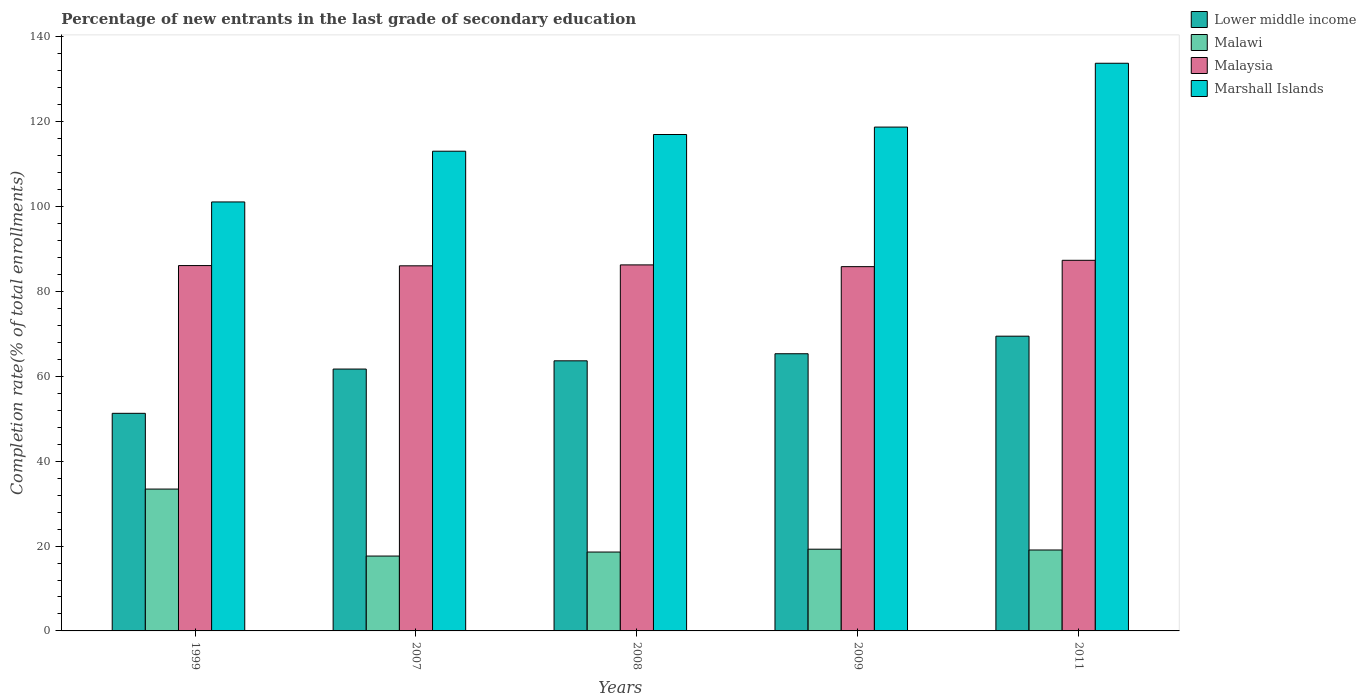How many different coloured bars are there?
Offer a terse response. 4. How many groups of bars are there?
Your answer should be compact. 5. Are the number of bars on each tick of the X-axis equal?
Your response must be concise. Yes. How many bars are there on the 1st tick from the left?
Your response must be concise. 4. How many bars are there on the 2nd tick from the right?
Give a very brief answer. 4. What is the label of the 1st group of bars from the left?
Your answer should be very brief. 1999. What is the percentage of new entrants in Lower middle income in 1999?
Offer a terse response. 51.28. Across all years, what is the maximum percentage of new entrants in Lower middle income?
Provide a succinct answer. 69.46. Across all years, what is the minimum percentage of new entrants in Malaysia?
Give a very brief answer. 85.85. In which year was the percentage of new entrants in Malaysia maximum?
Give a very brief answer. 2011. In which year was the percentage of new entrants in Malaysia minimum?
Make the answer very short. 2009. What is the total percentage of new entrants in Marshall Islands in the graph?
Ensure brevity in your answer.  583.65. What is the difference between the percentage of new entrants in Lower middle income in 2009 and that in 2011?
Provide a succinct answer. -4.14. What is the difference between the percentage of new entrants in Malawi in 2007 and the percentage of new entrants in Malaysia in 1999?
Provide a short and direct response. -68.46. What is the average percentage of new entrants in Marshall Islands per year?
Ensure brevity in your answer.  116.73. In the year 2007, what is the difference between the percentage of new entrants in Malaysia and percentage of new entrants in Lower middle income?
Give a very brief answer. 24.33. What is the ratio of the percentage of new entrants in Marshall Islands in 2009 to that in 2011?
Your response must be concise. 0.89. Is the difference between the percentage of new entrants in Malaysia in 2008 and 2011 greater than the difference between the percentage of new entrants in Lower middle income in 2008 and 2011?
Ensure brevity in your answer.  Yes. What is the difference between the highest and the second highest percentage of new entrants in Lower middle income?
Your response must be concise. 4.14. What is the difference between the highest and the lowest percentage of new entrants in Marshall Islands?
Provide a short and direct response. 32.68. Is it the case that in every year, the sum of the percentage of new entrants in Lower middle income and percentage of new entrants in Malaysia is greater than the sum of percentage of new entrants in Marshall Islands and percentage of new entrants in Malawi?
Offer a very short reply. Yes. What does the 4th bar from the left in 1999 represents?
Ensure brevity in your answer.  Marshall Islands. What does the 2nd bar from the right in 2009 represents?
Your answer should be compact. Malaysia. How many years are there in the graph?
Give a very brief answer. 5. What is the difference between two consecutive major ticks on the Y-axis?
Ensure brevity in your answer.  20. Are the values on the major ticks of Y-axis written in scientific E-notation?
Provide a succinct answer. No. How many legend labels are there?
Your answer should be very brief. 4. How are the legend labels stacked?
Give a very brief answer. Vertical. What is the title of the graph?
Your answer should be compact. Percentage of new entrants in the last grade of secondary education. What is the label or title of the Y-axis?
Your answer should be compact. Completion rate(% of total enrollments). What is the Completion rate(% of total enrollments) in Lower middle income in 1999?
Give a very brief answer. 51.28. What is the Completion rate(% of total enrollments) of Malawi in 1999?
Make the answer very short. 33.43. What is the Completion rate(% of total enrollments) in Malaysia in 1999?
Your response must be concise. 86.1. What is the Completion rate(% of total enrollments) in Marshall Islands in 1999?
Provide a succinct answer. 101.1. What is the Completion rate(% of total enrollments) of Lower middle income in 2007?
Offer a very short reply. 61.71. What is the Completion rate(% of total enrollments) of Malawi in 2007?
Your answer should be very brief. 17.64. What is the Completion rate(% of total enrollments) of Malaysia in 2007?
Your response must be concise. 86.04. What is the Completion rate(% of total enrollments) in Marshall Islands in 2007?
Offer a very short reply. 113.05. What is the Completion rate(% of total enrollments) of Lower middle income in 2008?
Offer a very short reply. 63.65. What is the Completion rate(% of total enrollments) in Malawi in 2008?
Your answer should be compact. 18.59. What is the Completion rate(% of total enrollments) in Malaysia in 2008?
Your answer should be very brief. 86.26. What is the Completion rate(% of total enrollments) of Marshall Islands in 2008?
Offer a very short reply. 116.99. What is the Completion rate(% of total enrollments) in Lower middle income in 2009?
Your answer should be compact. 65.32. What is the Completion rate(% of total enrollments) in Malawi in 2009?
Ensure brevity in your answer.  19.26. What is the Completion rate(% of total enrollments) in Malaysia in 2009?
Your response must be concise. 85.85. What is the Completion rate(% of total enrollments) of Marshall Islands in 2009?
Offer a very short reply. 118.74. What is the Completion rate(% of total enrollments) of Lower middle income in 2011?
Your answer should be very brief. 69.46. What is the Completion rate(% of total enrollments) of Malawi in 2011?
Keep it short and to the point. 19.07. What is the Completion rate(% of total enrollments) of Malaysia in 2011?
Your response must be concise. 87.34. What is the Completion rate(% of total enrollments) of Marshall Islands in 2011?
Provide a succinct answer. 133.78. Across all years, what is the maximum Completion rate(% of total enrollments) of Lower middle income?
Your response must be concise. 69.46. Across all years, what is the maximum Completion rate(% of total enrollments) in Malawi?
Your answer should be compact. 33.43. Across all years, what is the maximum Completion rate(% of total enrollments) of Malaysia?
Offer a terse response. 87.34. Across all years, what is the maximum Completion rate(% of total enrollments) in Marshall Islands?
Your answer should be very brief. 133.78. Across all years, what is the minimum Completion rate(% of total enrollments) in Lower middle income?
Give a very brief answer. 51.28. Across all years, what is the minimum Completion rate(% of total enrollments) in Malawi?
Make the answer very short. 17.64. Across all years, what is the minimum Completion rate(% of total enrollments) of Malaysia?
Your response must be concise. 85.85. Across all years, what is the minimum Completion rate(% of total enrollments) of Marshall Islands?
Provide a succinct answer. 101.1. What is the total Completion rate(% of total enrollments) in Lower middle income in the graph?
Make the answer very short. 311.43. What is the total Completion rate(% of total enrollments) of Malawi in the graph?
Offer a very short reply. 107.99. What is the total Completion rate(% of total enrollments) of Malaysia in the graph?
Offer a terse response. 431.6. What is the total Completion rate(% of total enrollments) in Marshall Islands in the graph?
Provide a succinct answer. 583.65. What is the difference between the Completion rate(% of total enrollments) in Lower middle income in 1999 and that in 2007?
Offer a very short reply. -10.43. What is the difference between the Completion rate(% of total enrollments) of Malawi in 1999 and that in 2007?
Ensure brevity in your answer.  15.78. What is the difference between the Completion rate(% of total enrollments) of Malaysia in 1999 and that in 2007?
Offer a very short reply. 0.06. What is the difference between the Completion rate(% of total enrollments) in Marshall Islands in 1999 and that in 2007?
Your answer should be compact. -11.96. What is the difference between the Completion rate(% of total enrollments) in Lower middle income in 1999 and that in 2008?
Your response must be concise. -12.37. What is the difference between the Completion rate(% of total enrollments) of Malawi in 1999 and that in 2008?
Provide a short and direct response. 14.84. What is the difference between the Completion rate(% of total enrollments) in Malaysia in 1999 and that in 2008?
Offer a very short reply. -0.16. What is the difference between the Completion rate(% of total enrollments) in Marshall Islands in 1999 and that in 2008?
Provide a short and direct response. -15.89. What is the difference between the Completion rate(% of total enrollments) in Lower middle income in 1999 and that in 2009?
Offer a very short reply. -14.04. What is the difference between the Completion rate(% of total enrollments) in Malawi in 1999 and that in 2009?
Give a very brief answer. 14.17. What is the difference between the Completion rate(% of total enrollments) of Malaysia in 1999 and that in 2009?
Make the answer very short. 0.26. What is the difference between the Completion rate(% of total enrollments) of Marshall Islands in 1999 and that in 2009?
Give a very brief answer. -17.64. What is the difference between the Completion rate(% of total enrollments) in Lower middle income in 1999 and that in 2011?
Offer a very short reply. -18.18. What is the difference between the Completion rate(% of total enrollments) in Malawi in 1999 and that in 2011?
Provide a succinct answer. 14.36. What is the difference between the Completion rate(% of total enrollments) in Malaysia in 1999 and that in 2011?
Give a very brief answer. -1.24. What is the difference between the Completion rate(% of total enrollments) in Marshall Islands in 1999 and that in 2011?
Your response must be concise. -32.68. What is the difference between the Completion rate(% of total enrollments) of Lower middle income in 2007 and that in 2008?
Keep it short and to the point. -1.94. What is the difference between the Completion rate(% of total enrollments) in Malawi in 2007 and that in 2008?
Your response must be concise. -0.94. What is the difference between the Completion rate(% of total enrollments) of Malaysia in 2007 and that in 2008?
Provide a short and direct response. -0.22. What is the difference between the Completion rate(% of total enrollments) of Marshall Islands in 2007 and that in 2008?
Give a very brief answer. -3.93. What is the difference between the Completion rate(% of total enrollments) in Lower middle income in 2007 and that in 2009?
Keep it short and to the point. -3.61. What is the difference between the Completion rate(% of total enrollments) in Malawi in 2007 and that in 2009?
Make the answer very short. -1.62. What is the difference between the Completion rate(% of total enrollments) in Malaysia in 2007 and that in 2009?
Offer a very short reply. 0.2. What is the difference between the Completion rate(% of total enrollments) of Marshall Islands in 2007 and that in 2009?
Make the answer very short. -5.68. What is the difference between the Completion rate(% of total enrollments) in Lower middle income in 2007 and that in 2011?
Your answer should be compact. -7.75. What is the difference between the Completion rate(% of total enrollments) of Malawi in 2007 and that in 2011?
Offer a very short reply. -1.43. What is the difference between the Completion rate(% of total enrollments) in Malaysia in 2007 and that in 2011?
Provide a succinct answer. -1.3. What is the difference between the Completion rate(% of total enrollments) in Marshall Islands in 2007 and that in 2011?
Ensure brevity in your answer.  -20.73. What is the difference between the Completion rate(% of total enrollments) of Lower middle income in 2008 and that in 2009?
Keep it short and to the point. -1.67. What is the difference between the Completion rate(% of total enrollments) of Malawi in 2008 and that in 2009?
Your answer should be compact. -0.67. What is the difference between the Completion rate(% of total enrollments) of Malaysia in 2008 and that in 2009?
Offer a very short reply. 0.41. What is the difference between the Completion rate(% of total enrollments) of Marshall Islands in 2008 and that in 2009?
Give a very brief answer. -1.75. What is the difference between the Completion rate(% of total enrollments) in Lower middle income in 2008 and that in 2011?
Ensure brevity in your answer.  -5.81. What is the difference between the Completion rate(% of total enrollments) in Malawi in 2008 and that in 2011?
Your answer should be very brief. -0.48. What is the difference between the Completion rate(% of total enrollments) of Malaysia in 2008 and that in 2011?
Offer a terse response. -1.08. What is the difference between the Completion rate(% of total enrollments) of Marshall Islands in 2008 and that in 2011?
Your answer should be very brief. -16.79. What is the difference between the Completion rate(% of total enrollments) of Lower middle income in 2009 and that in 2011?
Ensure brevity in your answer.  -4.14. What is the difference between the Completion rate(% of total enrollments) in Malawi in 2009 and that in 2011?
Provide a succinct answer. 0.19. What is the difference between the Completion rate(% of total enrollments) of Malaysia in 2009 and that in 2011?
Provide a short and direct response. -1.5. What is the difference between the Completion rate(% of total enrollments) of Marshall Islands in 2009 and that in 2011?
Your answer should be very brief. -15.04. What is the difference between the Completion rate(% of total enrollments) in Lower middle income in 1999 and the Completion rate(% of total enrollments) in Malawi in 2007?
Ensure brevity in your answer.  33.64. What is the difference between the Completion rate(% of total enrollments) of Lower middle income in 1999 and the Completion rate(% of total enrollments) of Malaysia in 2007?
Provide a succinct answer. -34.76. What is the difference between the Completion rate(% of total enrollments) of Lower middle income in 1999 and the Completion rate(% of total enrollments) of Marshall Islands in 2007?
Provide a short and direct response. -61.77. What is the difference between the Completion rate(% of total enrollments) of Malawi in 1999 and the Completion rate(% of total enrollments) of Malaysia in 2007?
Provide a short and direct response. -52.62. What is the difference between the Completion rate(% of total enrollments) in Malawi in 1999 and the Completion rate(% of total enrollments) in Marshall Islands in 2007?
Provide a short and direct response. -79.62. What is the difference between the Completion rate(% of total enrollments) in Malaysia in 1999 and the Completion rate(% of total enrollments) in Marshall Islands in 2007?
Your answer should be very brief. -26.95. What is the difference between the Completion rate(% of total enrollments) of Lower middle income in 1999 and the Completion rate(% of total enrollments) of Malawi in 2008?
Give a very brief answer. 32.69. What is the difference between the Completion rate(% of total enrollments) of Lower middle income in 1999 and the Completion rate(% of total enrollments) of Malaysia in 2008?
Give a very brief answer. -34.98. What is the difference between the Completion rate(% of total enrollments) in Lower middle income in 1999 and the Completion rate(% of total enrollments) in Marshall Islands in 2008?
Your answer should be compact. -65.71. What is the difference between the Completion rate(% of total enrollments) of Malawi in 1999 and the Completion rate(% of total enrollments) of Malaysia in 2008?
Ensure brevity in your answer.  -52.83. What is the difference between the Completion rate(% of total enrollments) in Malawi in 1999 and the Completion rate(% of total enrollments) in Marshall Islands in 2008?
Provide a succinct answer. -83.56. What is the difference between the Completion rate(% of total enrollments) of Malaysia in 1999 and the Completion rate(% of total enrollments) of Marshall Islands in 2008?
Provide a succinct answer. -30.89. What is the difference between the Completion rate(% of total enrollments) of Lower middle income in 1999 and the Completion rate(% of total enrollments) of Malawi in 2009?
Offer a very short reply. 32.02. What is the difference between the Completion rate(% of total enrollments) in Lower middle income in 1999 and the Completion rate(% of total enrollments) in Malaysia in 2009?
Your answer should be very brief. -34.57. What is the difference between the Completion rate(% of total enrollments) of Lower middle income in 1999 and the Completion rate(% of total enrollments) of Marshall Islands in 2009?
Offer a terse response. -67.46. What is the difference between the Completion rate(% of total enrollments) in Malawi in 1999 and the Completion rate(% of total enrollments) in Malaysia in 2009?
Your response must be concise. -52.42. What is the difference between the Completion rate(% of total enrollments) in Malawi in 1999 and the Completion rate(% of total enrollments) in Marshall Islands in 2009?
Offer a terse response. -85.31. What is the difference between the Completion rate(% of total enrollments) of Malaysia in 1999 and the Completion rate(% of total enrollments) of Marshall Islands in 2009?
Provide a succinct answer. -32.63. What is the difference between the Completion rate(% of total enrollments) in Lower middle income in 1999 and the Completion rate(% of total enrollments) in Malawi in 2011?
Give a very brief answer. 32.21. What is the difference between the Completion rate(% of total enrollments) in Lower middle income in 1999 and the Completion rate(% of total enrollments) in Malaysia in 2011?
Give a very brief answer. -36.06. What is the difference between the Completion rate(% of total enrollments) of Lower middle income in 1999 and the Completion rate(% of total enrollments) of Marshall Islands in 2011?
Ensure brevity in your answer.  -82.5. What is the difference between the Completion rate(% of total enrollments) of Malawi in 1999 and the Completion rate(% of total enrollments) of Malaysia in 2011?
Make the answer very short. -53.91. What is the difference between the Completion rate(% of total enrollments) of Malawi in 1999 and the Completion rate(% of total enrollments) of Marshall Islands in 2011?
Give a very brief answer. -100.35. What is the difference between the Completion rate(% of total enrollments) in Malaysia in 1999 and the Completion rate(% of total enrollments) in Marshall Islands in 2011?
Ensure brevity in your answer.  -47.68. What is the difference between the Completion rate(% of total enrollments) in Lower middle income in 2007 and the Completion rate(% of total enrollments) in Malawi in 2008?
Offer a very short reply. 43.12. What is the difference between the Completion rate(% of total enrollments) in Lower middle income in 2007 and the Completion rate(% of total enrollments) in Malaysia in 2008?
Provide a succinct answer. -24.55. What is the difference between the Completion rate(% of total enrollments) of Lower middle income in 2007 and the Completion rate(% of total enrollments) of Marshall Islands in 2008?
Give a very brief answer. -55.27. What is the difference between the Completion rate(% of total enrollments) in Malawi in 2007 and the Completion rate(% of total enrollments) in Malaysia in 2008?
Provide a short and direct response. -68.62. What is the difference between the Completion rate(% of total enrollments) in Malawi in 2007 and the Completion rate(% of total enrollments) in Marshall Islands in 2008?
Provide a succinct answer. -99.34. What is the difference between the Completion rate(% of total enrollments) of Malaysia in 2007 and the Completion rate(% of total enrollments) of Marshall Islands in 2008?
Your response must be concise. -30.94. What is the difference between the Completion rate(% of total enrollments) in Lower middle income in 2007 and the Completion rate(% of total enrollments) in Malawi in 2009?
Provide a short and direct response. 42.45. What is the difference between the Completion rate(% of total enrollments) in Lower middle income in 2007 and the Completion rate(% of total enrollments) in Malaysia in 2009?
Provide a short and direct response. -24.13. What is the difference between the Completion rate(% of total enrollments) of Lower middle income in 2007 and the Completion rate(% of total enrollments) of Marshall Islands in 2009?
Keep it short and to the point. -57.02. What is the difference between the Completion rate(% of total enrollments) of Malawi in 2007 and the Completion rate(% of total enrollments) of Malaysia in 2009?
Your response must be concise. -68.2. What is the difference between the Completion rate(% of total enrollments) of Malawi in 2007 and the Completion rate(% of total enrollments) of Marshall Islands in 2009?
Keep it short and to the point. -101.09. What is the difference between the Completion rate(% of total enrollments) of Malaysia in 2007 and the Completion rate(% of total enrollments) of Marshall Islands in 2009?
Offer a very short reply. -32.69. What is the difference between the Completion rate(% of total enrollments) of Lower middle income in 2007 and the Completion rate(% of total enrollments) of Malawi in 2011?
Provide a short and direct response. 42.64. What is the difference between the Completion rate(% of total enrollments) in Lower middle income in 2007 and the Completion rate(% of total enrollments) in Malaysia in 2011?
Your answer should be very brief. -25.63. What is the difference between the Completion rate(% of total enrollments) in Lower middle income in 2007 and the Completion rate(% of total enrollments) in Marshall Islands in 2011?
Make the answer very short. -72.07. What is the difference between the Completion rate(% of total enrollments) of Malawi in 2007 and the Completion rate(% of total enrollments) of Malaysia in 2011?
Give a very brief answer. -69.7. What is the difference between the Completion rate(% of total enrollments) in Malawi in 2007 and the Completion rate(% of total enrollments) in Marshall Islands in 2011?
Ensure brevity in your answer.  -116.14. What is the difference between the Completion rate(% of total enrollments) of Malaysia in 2007 and the Completion rate(% of total enrollments) of Marshall Islands in 2011?
Your answer should be compact. -47.74. What is the difference between the Completion rate(% of total enrollments) of Lower middle income in 2008 and the Completion rate(% of total enrollments) of Malawi in 2009?
Your answer should be compact. 44.39. What is the difference between the Completion rate(% of total enrollments) of Lower middle income in 2008 and the Completion rate(% of total enrollments) of Malaysia in 2009?
Your answer should be very brief. -22.19. What is the difference between the Completion rate(% of total enrollments) of Lower middle income in 2008 and the Completion rate(% of total enrollments) of Marshall Islands in 2009?
Your answer should be very brief. -55.08. What is the difference between the Completion rate(% of total enrollments) in Malawi in 2008 and the Completion rate(% of total enrollments) in Malaysia in 2009?
Your answer should be very brief. -67.26. What is the difference between the Completion rate(% of total enrollments) in Malawi in 2008 and the Completion rate(% of total enrollments) in Marshall Islands in 2009?
Your response must be concise. -100.15. What is the difference between the Completion rate(% of total enrollments) in Malaysia in 2008 and the Completion rate(% of total enrollments) in Marshall Islands in 2009?
Make the answer very short. -32.47. What is the difference between the Completion rate(% of total enrollments) in Lower middle income in 2008 and the Completion rate(% of total enrollments) in Malawi in 2011?
Make the answer very short. 44.58. What is the difference between the Completion rate(% of total enrollments) of Lower middle income in 2008 and the Completion rate(% of total enrollments) of Malaysia in 2011?
Keep it short and to the point. -23.69. What is the difference between the Completion rate(% of total enrollments) of Lower middle income in 2008 and the Completion rate(% of total enrollments) of Marshall Islands in 2011?
Offer a very short reply. -70.13. What is the difference between the Completion rate(% of total enrollments) of Malawi in 2008 and the Completion rate(% of total enrollments) of Malaysia in 2011?
Keep it short and to the point. -68.75. What is the difference between the Completion rate(% of total enrollments) in Malawi in 2008 and the Completion rate(% of total enrollments) in Marshall Islands in 2011?
Keep it short and to the point. -115.19. What is the difference between the Completion rate(% of total enrollments) of Malaysia in 2008 and the Completion rate(% of total enrollments) of Marshall Islands in 2011?
Your response must be concise. -47.52. What is the difference between the Completion rate(% of total enrollments) of Lower middle income in 2009 and the Completion rate(% of total enrollments) of Malawi in 2011?
Offer a very short reply. 46.25. What is the difference between the Completion rate(% of total enrollments) in Lower middle income in 2009 and the Completion rate(% of total enrollments) in Malaysia in 2011?
Offer a terse response. -22.02. What is the difference between the Completion rate(% of total enrollments) in Lower middle income in 2009 and the Completion rate(% of total enrollments) in Marshall Islands in 2011?
Give a very brief answer. -68.46. What is the difference between the Completion rate(% of total enrollments) of Malawi in 2009 and the Completion rate(% of total enrollments) of Malaysia in 2011?
Provide a succinct answer. -68.08. What is the difference between the Completion rate(% of total enrollments) of Malawi in 2009 and the Completion rate(% of total enrollments) of Marshall Islands in 2011?
Give a very brief answer. -114.52. What is the difference between the Completion rate(% of total enrollments) in Malaysia in 2009 and the Completion rate(% of total enrollments) in Marshall Islands in 2011?
Provide a short and direct response. -47.93. What is the average Completion rate(% of total enrollments) of Lower middle income per year?
Provide a succinct answer. 62.29. What is the average Completion rate(% of total enrollments) of Malawi per year?
Your answer should be very brief. 21.6. What is the average Completion rate(% of total enrollments) of Malaysia per year?
Your answer should be compact. 86.32. What is the average Completion rate(% of total enrollments) in Marshall Islands per year?
Your response must be concise. 116.73. In the year 1999, what is the difference between the Completion rate(% of total enrollments) of Lower middle income and Completion rate(% of total enrollments) of Malawi?
Ensure brevity in your answer.  17.85. In the year 1999, what is the difference between the Completion rate(% of total enrollments) of Lower middle income and Completion rate(% of total enrollments) of Malaysia?
Keep it short and to the point. -34.82. In the year 1999, what is the difference between the Completion rate(% of total enrollments) of Lower middle income and Completion rate(% of total enrollments) of Marshall Islands?
Provide a short and direct response. -49.82. In the year 1999, what is the difference between the Completion rate(% of total enrollments) of Malawi and Completion rate(% of total enrollments) of Malaysia?
Your answer should be compact. -52.67. In the year 1999, what is the difference between the Completion rate(% of total enrollments) in Malawi and Completion rate(% of total enrollments) in Marshall Islands?
Your answer should be very brief. -67.67. In the year 1999, what is the difference between the Completion rate(% of total enrollments) of Malaysia and Completion rate(% of total enrollments) of Marshall Islands?
Your answer should be compact. -15. In the year 2007, what is the difference between the Completion rate(% of total enrollments) of Lower middle income and Completion rate(% of total enrollments) of Malawi?
Give a very brief answer. 44.07. In the year 2007, what is the difference between the Completion rate(% of total enrollments) in Lower middle income and Completion rate(% of total enrollments) in Malaysia?
Provide a short and direct response. -24.33. In the year 2007, what is the difference between the Completion rate(% of total enrollments) of Lower middle income and Completion rate(% of total enrollments) of Marshall Islands?
Your answer should be compact. -51.34. In the year 2007, what is the difference between the Completion rate(% of total enrollments) in Malawi and Completion rate(% of total enrollments) in Malaysia?
Keep it short and to the point. -68.4. In the year 2007, what is the difference between the Completion rate(% of total enrollments) in Malawi and Completion rate(% of total enrollments) in Marshall Islands?
Your answer should be compact. -95.41. In the year 2007, what is the difference between the Completion rate(% of total enrollments) of Malaysia and Completion rate(% of total enrollments) of Marshall Islands?
Your answer should be compact. -27.01. In the year 2008, what is the difference between the Completion rate(% of total enrollments) of Lower middle income and Completion rate(% of total enrollments) of Malawi?
Your answer should be compact. 45.07. In the year 2008, what is the difference between the Completion rate(% of total enrollments) of Lower middle income and Completion rate(% of total enrollments) of Malaysia?
Your answer should be compact. -22.61. In the year 2008, what is the difference between the Completion rate(% of total enrollments) in Lower middle income and Completion rate(% of total enrollments) in Marshall Islands?
Keep it short and to the point. -53.33. In the year 2008, what is the difference between the Completion rate(% of total enrollments) of Malawi and Completion rate(% of total enrollments) of Malaysia?
Offer a very short reply. -67.67. In the year 2008, what is the difference between the Completion rate(% of total enrollments) of Malawi and Completion rate(% of total enrollments) of Marshall Islands?
Your answer should be compact. -98.4. In the year 2008, what is the difference between the Completion rate(% of total enrollments) in Malaysia and Completion rate(% of total enrollments) in Marshall Islands?
Your response must be concise. -30.73. In the year 2009, what is the difference between the Completion rate(% of total enrollments) of Lower middle income and Completion rate(% of total enrollments) of Malawi?
Give a very brief answer. 46.06. In the year 2009, what is the difference between the Completion rate(% of total enrollments) of Lower middle income and Completion rate(% of total enrollments) of Malaysia?
Your answer should be very brief. -20.53. In the year 2009, what is the difference between the Completion rate(% of total enrollments) of Lower middle income and Completion rate(% of total enrollments) of Marshall Islands?
Your response must be concise. -53.42. In the year 2009, what is the difference between the Completion rate(% of total enrollments) of Malawi and Completion rate(% of total enrollments) of Malaysia?
Offer a very short reply. -66.59. In the year 2009, what is the difference between the Completion rate(% of total enrollments) in Malawi and Completion rate(% of total enrollments) in Marshall Islands?
Provide a succinct answer. -99.48. In the year 2009, what is the difference between the Completion rate(% of total enrollments) of Malaysia and Completion rate(% of total enrollments) of Marshall Islands?
Offer a terse response. -32.89. In the year 2011, what is the difference between the Completion rate(% of total enrollments) of Lower middle income and Completion rate(% of total enrollments) of Malawi?
Keep it short and to the point. 50.39. In the year 2011, what is the difference between the Completion rate(% of total enrollments) in Lower middle income and Completion rate(% of total enrollments) in Malaysia?
Your answer should be compact. -17.88. In the year 2011, what is the difference between the Completion rate(% of total enrollments) in Lower middle income and Completion rate(% of total enrollments) in Marshall Islands?
Make the answer very short. -64.32. In the year 2011, what is the difference between the Completion rate(% of total enrollments) of Malawi and Completion rate(% of total enrollments) of Malaysia?
Keep it short and to the point. -68.27. In the year 2011, what is the difference between the Completion rate(% of total enrollments) in Malawi and Completion rate(% of total enrollments) in Marshall Islands?
Offer a very short reply. -114.71. In the year 2011, what is the difference between the Completion rate(% of total enrollments) of Malaysia and Completion rate(% of total enrollments) of Marshall Islands?
Your answer should be very brief. -46.44. What is the ratio of the Completion rate(% of total enrollments) in Lower middle income in 1999 to that in 2007?
Offer a terse response. 0.83. What is the ratio of the Completion rate(% of total enrollments) of Malawi in 1999 to that in 2007?
Give a very brief answer. 1.89. What is the ratio of the Completion rate(% of total enrollments) in Malaysia in 1999 to that in 2007?
Offer a very short reply. 1. What is the ratio of the Completion rate(% of total enrollments) of Marshall Islands in 1999 to that in 2007?
Offer a terse response. 0.89. What is the ratio of the Completion rate(% of total enrollments) in Lower middle income in 1999 to that in 2008?
Provide a succinct answer. 0.81. What is the ratio of the Completion rate(% of total enrollments) of Malawi in 1999 to that in 2008?
Your answer should be very brief. 1.8. What is the ratio of the Completion rate(% of total enrollments) of Malaysia in 1999 to that in 2008?
Offer a very short reply. 1. What is the ratio of the Completion rate(% of total enrollments) in Marshall Islands in 1999 to that in 2008?
Ensure brevity in your answer.  0.86. What is the ratio of the Completion rate(% of total enrollments) of Lower middle income in 1999 to that in 2009?
Your response must be concise. 0.79. What is the ratio of the Completion rate(% of total enrollments) of Malawi in 1999 to that in 2009?
Offer a very short reply. 1.74. What is the ratio of the Completion rate(% of total enrollments) of Malaysia in 1999 to that in 2009?
Ensure brevity in your answer.  1. What is the ratio of the Completion rate(% of total enrollments) in Marshall Islands in 1999 to that in 2009?
Provide a short and direct response. 0.85. What is the ratio of the Completion rate(% of total enrollments) in Lower middle income in 1999 to that in 2011?
Give a very brief answer. 0.74. What is the ratio of the Completion rate(% of total enrollments) in Malawi in 1999 to that in 2011?
Keep it short and to the point. 1.75. What is the ratio of the Completion rate(% of total enrollments) in Malaysia in 1999 to that in 2011?
Keep it short and to the point. 0.99. What is the ratio of the Completion rate(% of total enrollments) of Marshall Islands in 1999 to that in 2011?
Your response must be concise. 0.76. What is the ratio of the Completion rate(% of total enrollments) of Lower middle income in 2007 to that in 2008?
Ensure brevity in your answer.  0.97. What is the ratio of the Completion rate(% of total enrollments) of Malawi in 2007 to that in 2008?
Your answer should be compact. 0.95. What is the ratio of the Completion rate(% of total enrollments) in Marshall Islands in 2007 to that in 2008?
Provide a succinct answer. 0.97. What is the ratio of the Completion rate(% of total enrollments) of Lower middle income in 2007 to that in 2009?
Keep it short and to the point. 0.94. What is the ratio of the Completion rate(% of total enrollments) in Malawi in 2007 to that in 2009?
Your answer should be very brief. 0.92. What is the ratio of the Completion rate(% of total enrollments) in Marshall Islands in 2007 to that in 2009?
Offer a very short reply. 0.95. What is the ratio of the Completion rate(% of total enrollments) in Lower middle income in 2007 to that in 2011?
Your answer should be compact. 0.89. What is the ratio of the Completion rate(% of total enrollments) of Malawi in 2007 to that in 2011?
Give a very brief answer. 0.93. What is the ratio of the Completion rate(% of total enrollments) of Malaysia in 2007 to that in 2011?
Your answer should be compact. 0.99. What is the ratio of the Completion rate(% of total enrollments) in Marshall Islands in 2007 to that in 2011?
Keep it short and to the point. 0.85. What is the ratio of the Completion rate(% of total enrollments) of Lower middle income in 2008 to that in 2009?
Offer a terse response. 0.97. What is the ratio of the Completion rate(% of total enrollments) of Malawi in 2008 to that in 2009?
Offer a terse response. 0.97. What is the ratio of the Completion rate(% of total enrollments) in Malaysia in 2008 to that in 2009?
Provide a short and direct response. 1. What is the ratio of the Completion rate(% of total enrollments) in Lower middle income in 2008 to that in 2011?
Ensure brevity in your answer.  0.92. What is the ratio of the Completion rate(% of total enrollments) of Malawi in 2008 to that in 2011?
Offer a very short reply. 0.97. What is the ratio of the Completion rate(% of total enrollments) of Malaysia in 2008 to that in 2011?
Your response must be concise. 0.99. What is the ratio of the Completion rate(% of total enrollments) in Marshall Islands in 2008 to that in 2011?
Provide a succinct answer. 0.87. What is the ratio of the Completion rate(% of total enrollments) of Lower middle income in 2009 to that in 2011?
Your answer should be very brief. 0.94. What is the ratio of the Completion rate(% of total enrollments) of Malawi in 2009 to that in 2011?
Provide a succinct answer. 1.01. What is the ratio of the Completion rate(% of total enrollments) of Malaysia in 2009 to that in 2011?
Make the answer very short. 0.98. What is the ratio of the Completion rate(% of total enrollments) of Marshall Islands in 2009 to that in 2011?
Your response must be concise. 0.89. What is the difference between the highest and the second highest Completion rate(% of total enrollments) of Lower middle income?
Your answer should be compact. 4.14. What is the difference between the highest and the second highest Completion rate(% of total enrollments) in Malawi?
Ensure brevity in your answer.  14.17. What is the difference between the highest and the second highest Completion rate(% of total enrollments) of Malaysia?
Keep it short and to the point. 1.08. What is the difference between the highest and the second highest Completion rate(% of total enrollments) of Marshall Islands?
Make the answer very short. 15.04. What is the difference between the highest and the lowest Completion rate(% of total enrollments) of Lower middle income?
Ensure brevity in your answer.  18.18. What is the difference between the highest and the lowest Completion rate(% of total enrollments) in Malawi?
Make the answer very short. 15.78. What is the difference between the highest and the lowest Completion rate(% of total enrollments) in Malaysia?
Provide a succinct answer. 1.5. What is the difference between the highest and the lowest Completion rate(% of total enrollments) in Marshall Islands?
Offer a terse response. 32.68. 